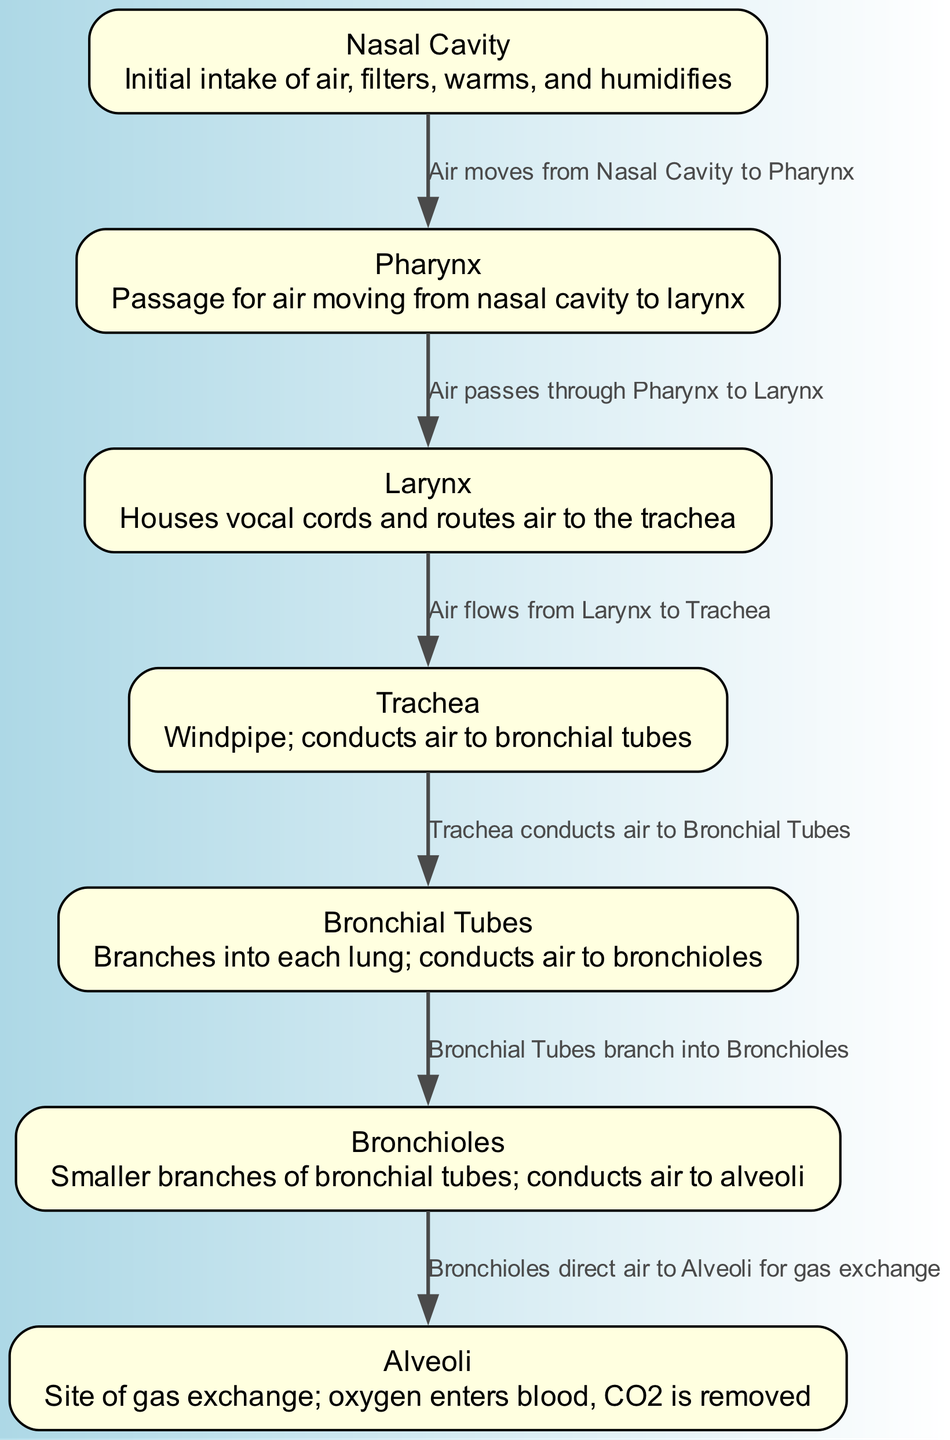What is the first structure air passes through in the respiratory system? According to the diagram, the first structure that air enters is the Nasal Cavity. This is indicated as the starting point of the air flow in the respiratory system.
Answer: Nasal Cavity How many nodes represent different structures in the diagram? The diagram contains 7 nodes, each representing a distinct structure in the human respiratory system. This is counted as each node listed in the data.
Answer: 7 What passage does air take after the Pharynx? The diagram shows that after passing through the Pharynx, air moves to the Larynx. This is represented as a direct edge connecting these two nodes.
Answer: Larynx What is the function of the Alveoli as per the diagram? The diagram states that the Alveoli are the site of gas exchange, where oxygen enters the blood and carbon dioxide is removed. This is the primary function described for this structure.
Answer: Site of gas exchange What is the flow sequence of air from the Trachea? The sequence of air flow from the Trachea is as follows: it conducts air to the Bronchial Tubes, which then branch into Bronchioles, and finally direct air to the Alveoli. This flow can be traced through the edges connecting these nodes in the diagram.
Answer: Bronchial Tubes How does air travel from the Bronchial Tubes to the Alveoli? The diagram shows that air travels from the Bronchial Tubes directly to the Bronchioles, which in turn directs air to the Alveoli for gas exchange, as indicated by the edges connecting these structures.
Answer: Through Bronchioles Which structure directly filters, warms, and humidifies the air? The diagram describes the Nasal Cavity as the structure that filters, warms, and humidifies the air when it is initially taken in. This is noted in the description of the Nasal Cavity node.
Answer: Nasal Cavity What is the pathway of air from the Larynx to the Bronchial Tubes? According to the diagram, air flows from the Larynx to the Trachea and then is directed to the Bronchial Tubes. Each segment is connected sequentially as shown in the edges of the diagram.
Answer: Trachea In the flow of air, which part does not have a direct connection to the Larynx? The diagram indicates that the Nasal Cavity does not have a direct connection to the Larynx; rather, it connects through the Pharynx. This connection is defined in the flow sequence.
Answer: Nasal Cavity 